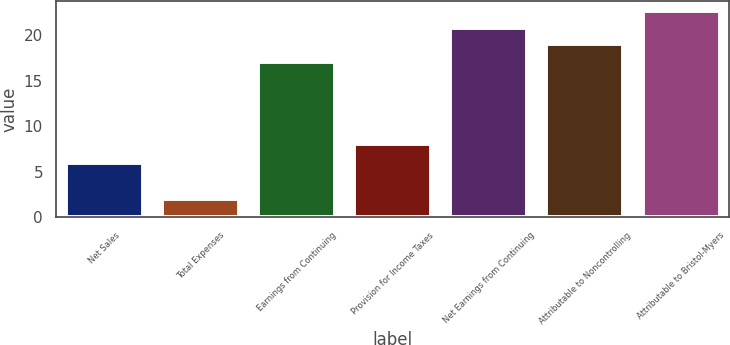Convert chart to OTSL. <chart><loc_0><loc_0><loc_500><loc_500><bar_chart><fcel>Net Sales<fcel>Total Expenses<fcel>Earnings from Continuing<fcel>Provision for Income Taxes<fcel>Net Earnings from Continuing<fcel>Attributable to Noncontrolling<fcel>Attributable to Bristol-Myers<nl><fcel>6<fcel>2<fcel>17<fcel>8<fcel>20.8<fcel>19<fcel>22.6<nl></chart> 